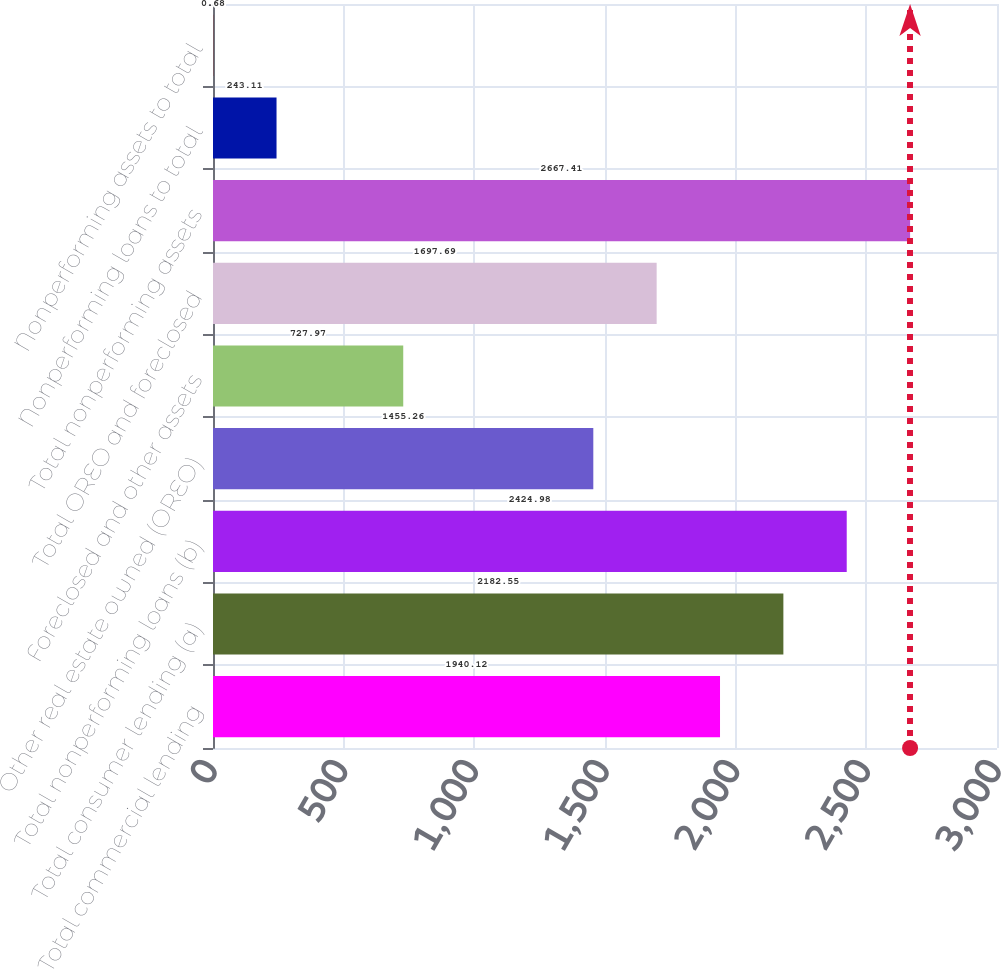Convert chart. <chart><loc_0><loc_0><loc_500><loc_500><bar_chart><fcel>Total commercial lending<fcel>Total consumer lending (a)<fcel>Total nonperforming loans (b)<fcel>Other real estate owned (OREO)<fcel>Foreclosed and other assets<fcel>Total OREO and foreclosed<fcel>Total nonperforming assets<fcel>Nonperforming loans to total<fcel>Nonperforming assets to total<nl><fcel>1940.12<fcel>2182.55<fcel>2424.98<fcel>1455.26<fcel>727.97<fcel>1697.69<fcel>2667.41<fcel>243.11<fcel>0.68<nl></chart> 